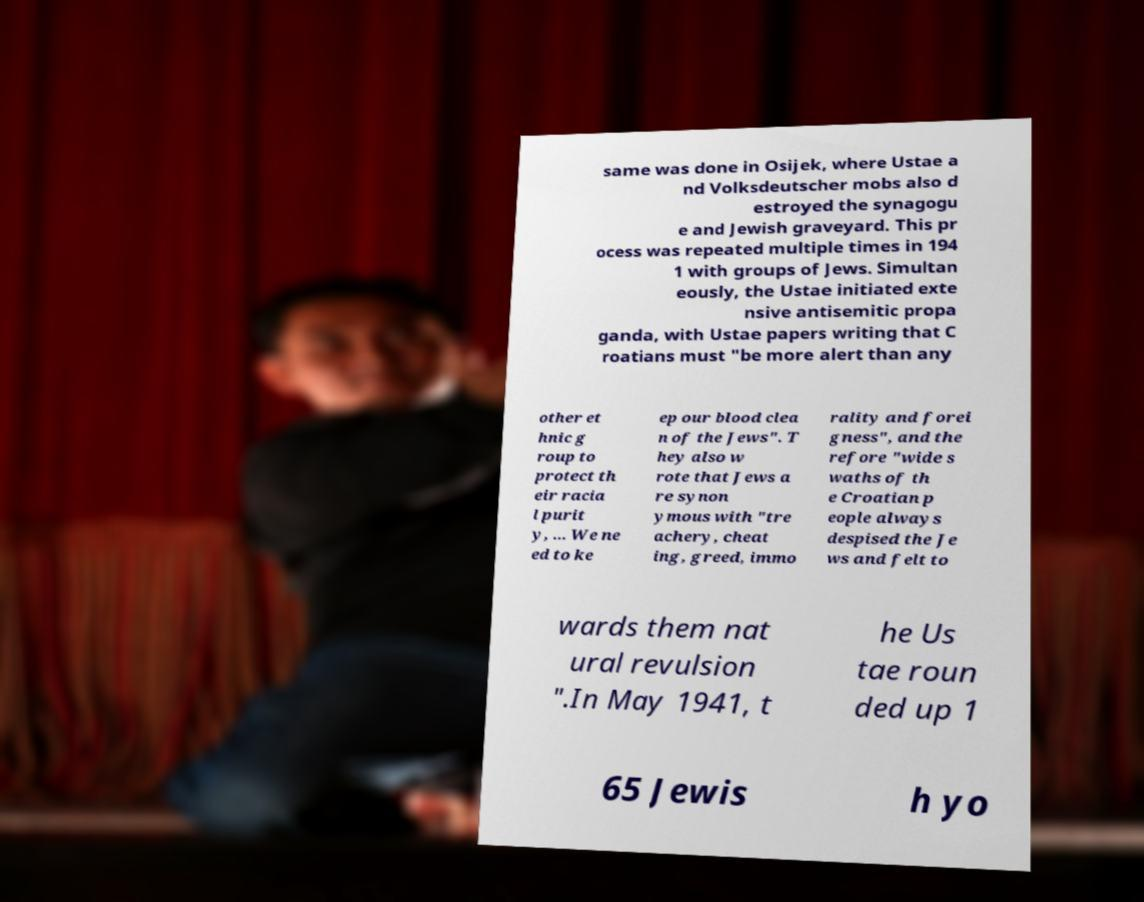I need the written content from this picture converted into text. Can you do that? same was done in Osijek, where Ustae a nd Volksdeutscher mobs also d estroyed the synagogu e and Jewish graveyard. This pr ocess was repeated multiple times in 194 1 with groups of Jews. Simultan eously, the Ustae initiated exte nsive antisemitic propa ganda, with Ustae papers writing that C roatians must "be more alert than any other et hnic g roup to protect th eir racia l purit y, ... We ne ed to ke ep our blood clea n of the Jews". T hey also w rote that Jews a re synon ymous with "tre achery, cheat ing, greed, immo rality and forei gness", and the refore "wide s waths of th e Croatian p eople always despised the Je ws and felt to wards them nat ural revulsion ".In May 1941, t he Us tae roun ded up 1 65 Jewis h yo 